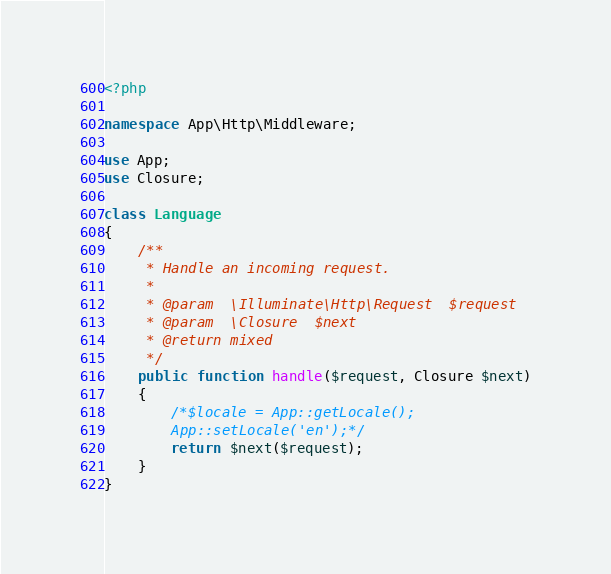<code> <loc_0><loc_0><loc_500><loc_500><_PHP_><?php

namespace App\Http\Middleware;

use App;
use Closure;

class Language
{
    /**
     * Handle an incoming request.
     *
     * @param  \Illuminate\Http\Request  $request
     * @param  \Closure  $next
     * @return mixed
     */
    public function handle($request, Closure $next)
    {
        /*$locale = App::getLocale();
        App::setLocale('en');*/
        return $next($request);       
    }
}
</code> 